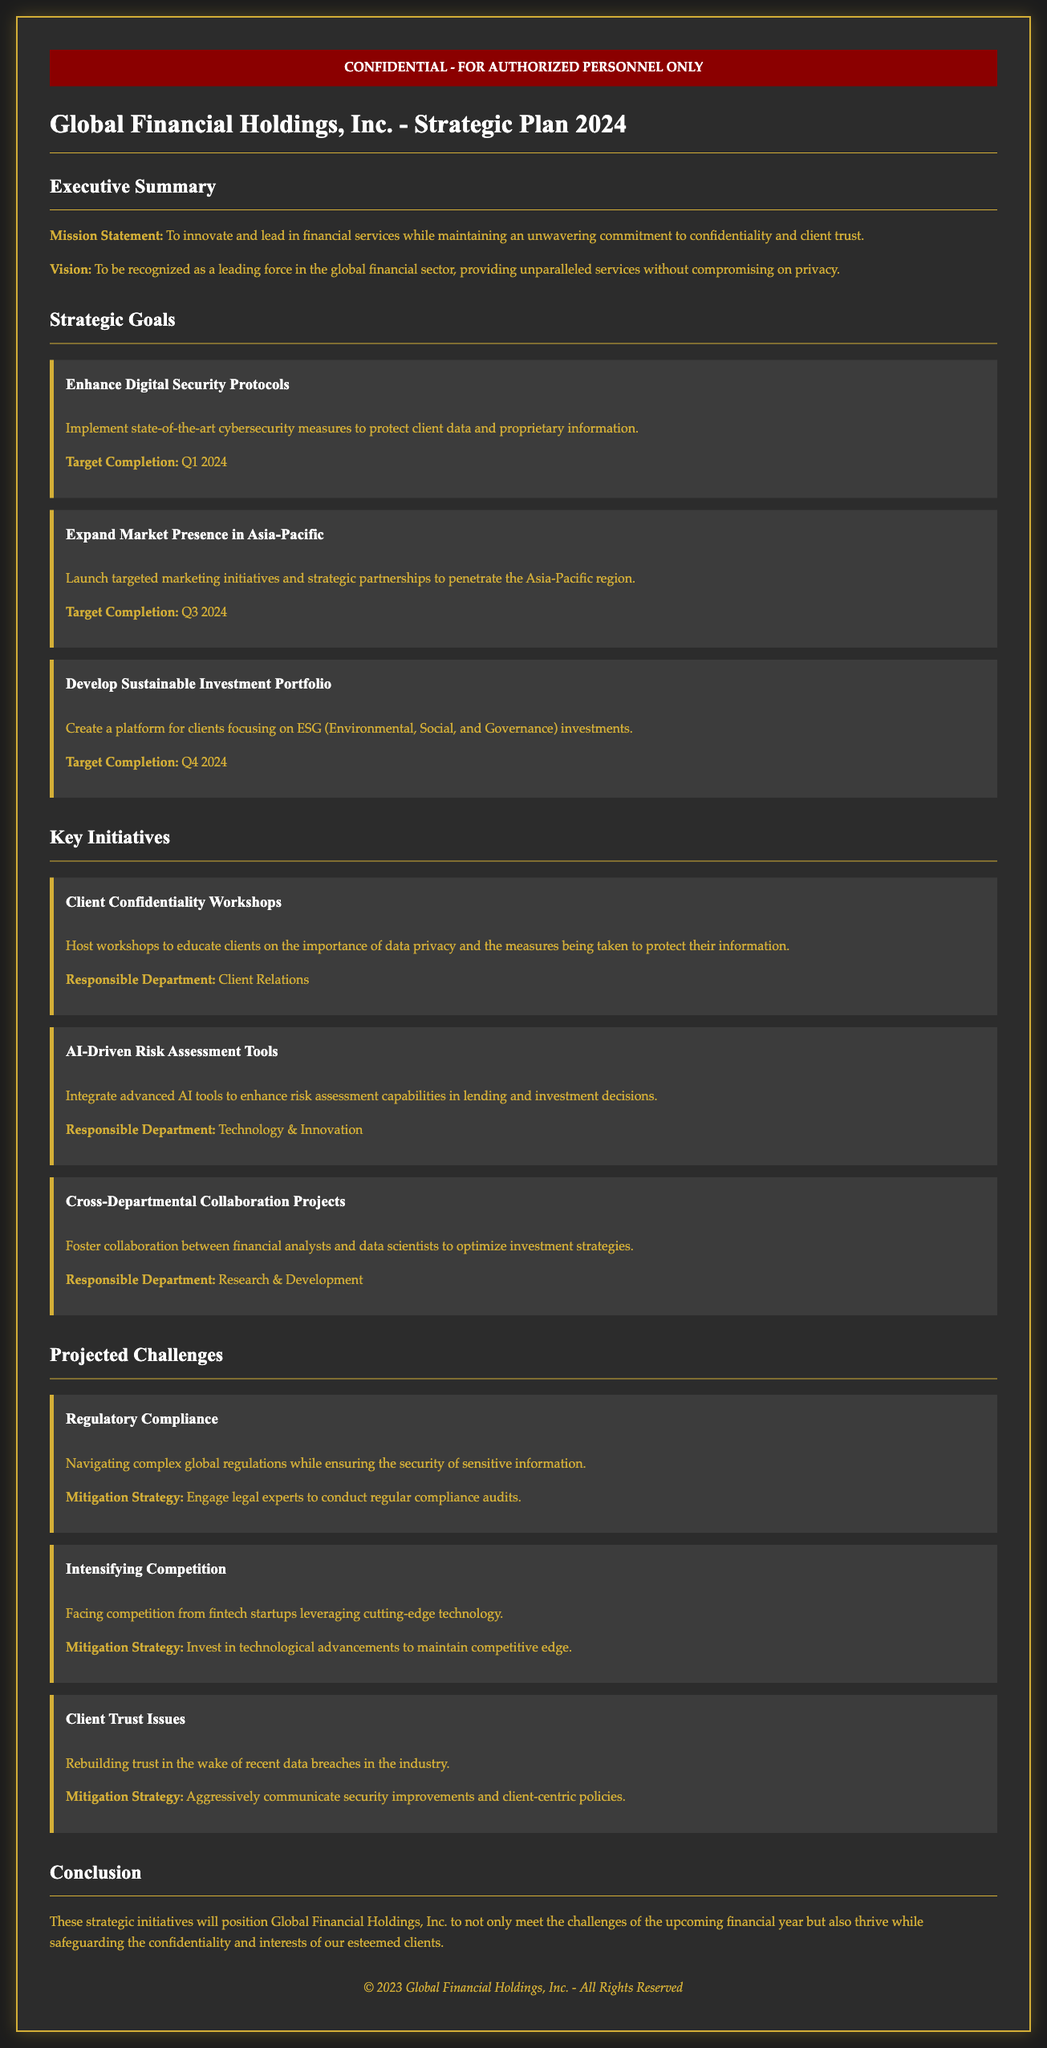what is the mission statement? The mission statement is outlined in the executive summary of the document, emphasizing innovation and client trust.
Answer: To innovate and lead in financial services while maintaining an unwavering commitment to confidentiality and client trust what is the target completion for enhancing digital security protocols? This goal includes a specified deadline for completion found in the strategic goals section.
Answer: Q1 2024 what initiative is related to client confidentiality? The initiatives section describes various programs, one specifically aimed at client confidentiality.
Answer: Client Confidentiality Workshops what is the first projected challenge mentioned? The challenges section lists various issues the organization anticipates facing, starting with regulatory compliance.
Answer: Regulatory Compliance which department is responsible for the AI-Driven Risk Assessment Tools initiative? Each initiative identifies a responsible department, which can be found in the initiatives section.
Answer: Technology & Innovation what is the mitigation strategy for client trust issues? The document outlines strategies for each challenge, including how to address issues related to client trust.
Answer: Aggressively communicate security improvements and client-centric policies how many strategic goals are outlined in the document? The strategic goals section lists individual goals, which can be counted for the total.
Answer: Three what is the vision of Global Financial Holdings, Inc.? The vision is stated in the executive summary, describing the organization's aspirations in the financial sector.
Answer: To be recognized as a leading force in the global financial sector, providing unparalleled services without compromising on privacy what is the target completion for developing a sustainable investment portfolio? The deadline for this goal is mentioned in the strategic goals section, which is clear for reference.
Answer: Q4 2024 